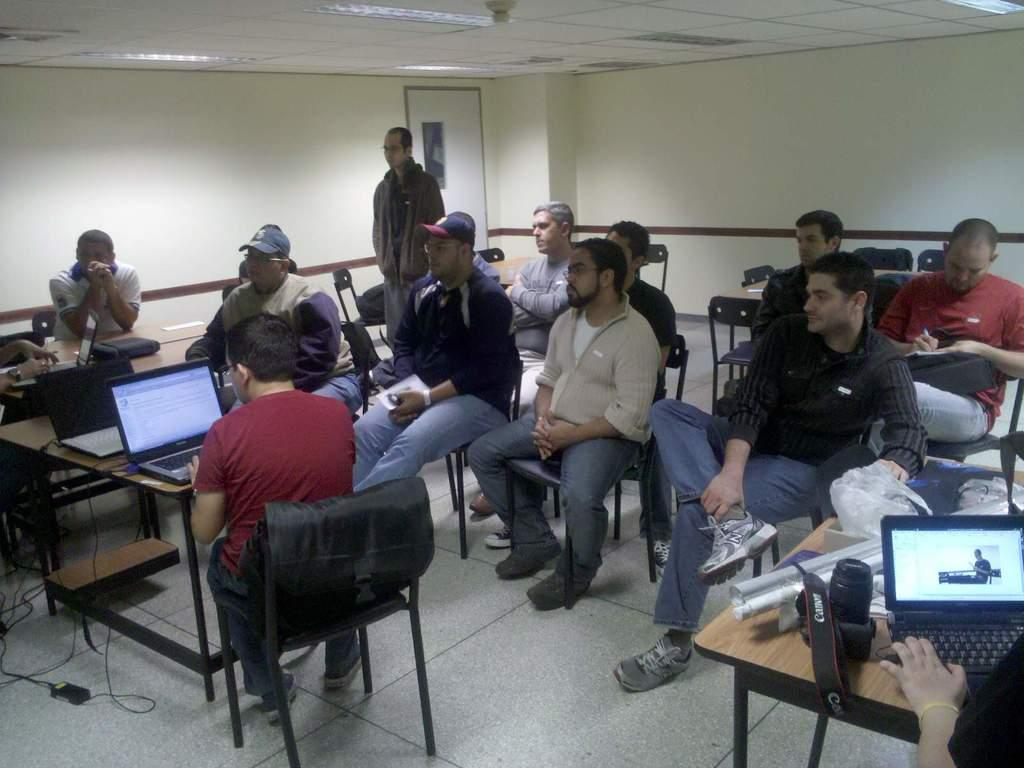What are the people in the image doing? The people in the image are sitting on chairs. What objects can be seen on the table in the image? There are laptops and a camera on the table in the image. How many dogs are present in the image? There are no dogs present in the image. What type of fish can be seen swimming in the background of the image? There is no fish visible in the image; it features people sitting on chairs and objects on a table. 